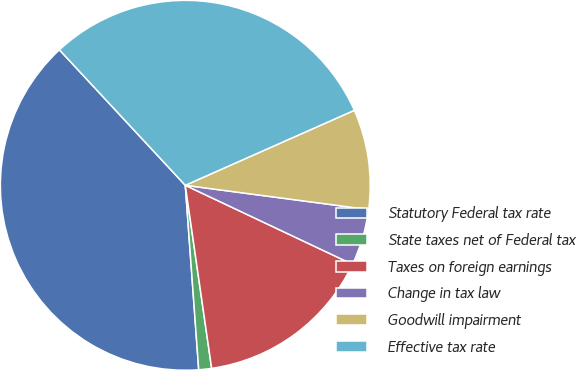Convert chart to OTSL. <chart><loc_0><loc_0><loc_500><loc_500><pie_chart><fcel>Statutory Federal tax rate<fcel>State taxes net of Federal tax<fcel>Taxes on foreign earnings<fcel>Change in tax law<fcel>Goodwill impairment<fcel>Effective tax rate<nl><fcel>39.24%<fcel>1.12%<fcel>15.7%<fcel>4.93%<fcel>8.74%<fcel>30.27%<nl></chart> 